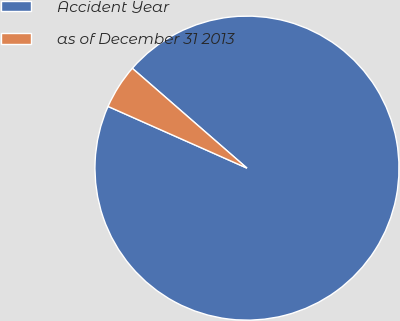Convert chart. <chart><loc_0><loc_0><loc_500><loc_500><pie_chart><fcel>Accident Year<fcel>as of December 31 2013<nl><fcel>95.25%<fcel>4.75%<nl></chart> 